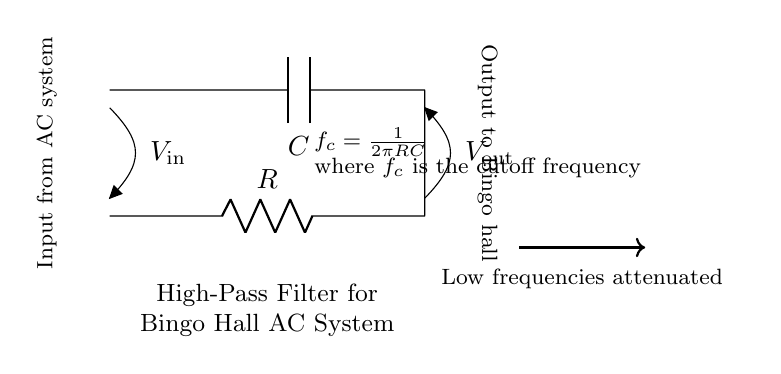What is the input voltage labeled on this circuit? The input voltage is labeled as V_in, indicating the voltage entering the circuit from the AC system.
Answer: V_in What are the two main components used in this high-pass filter? The circuit contains a resistor (R) and a capacitor (C), which are the essential components for filtering.
Answer: Resistor and Capacitor What is the purpose of the high-pass filter in this circuit? The high-pass filter is designed to allow high frequencies to pass while attenuating low frequencies, improving the sound quality in the Bingo hall.
Answer: Allows high frequencies to pass What is the cutoff frequency formula provided in the circuit? The cutoff frequency f_c is calculated using the formula f_c = 1/(2πRC), which describes the frequency at which the filter starts to attenuate lower frequencies.
Answer: f_c = 1/(2πRC) What happens to low frequencies in this high-pass filter? Low frequencies are attenuated, meaning they are reduced or eliminated from the output of the circuit, resulting in clearer sound.
Answer: Attenuated How is the output voltage labeled in this circuit? The output voltage is labeled as V_out, indicating the voltage after the filtering process before reaching the Bingo hall.
Answer: V_out 